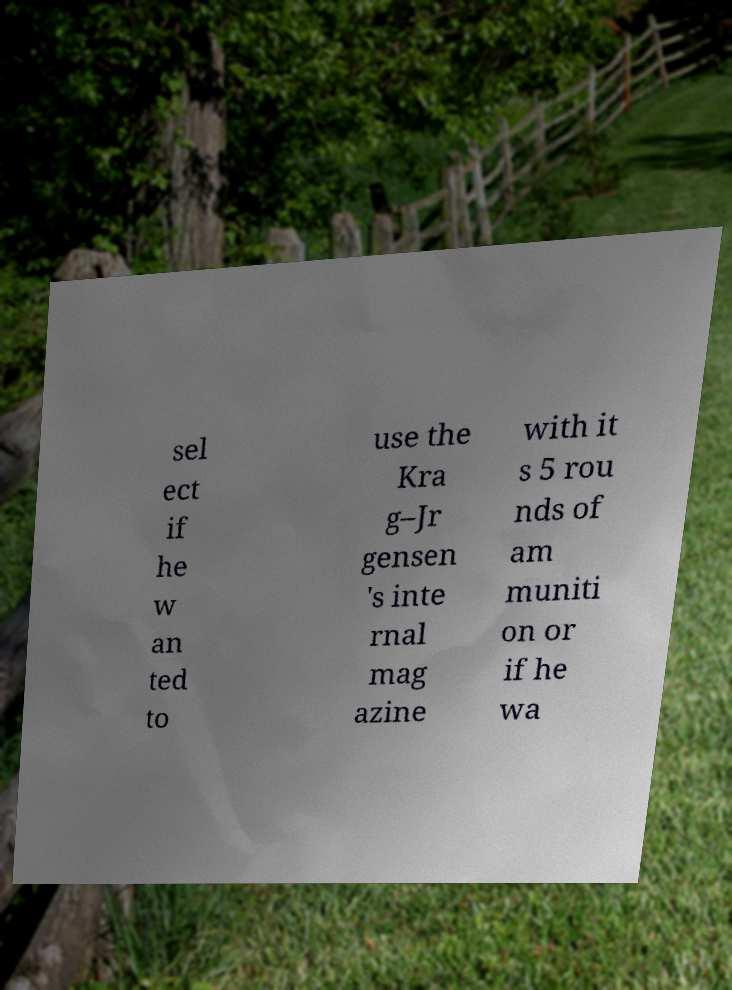Please identify and transcribe the text found in this image. sel ect if he w an ted to use the Kra g–Jr gensen 's inte rnal mag azine with it s 5 rou nds of am muniti on or if he wa 